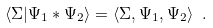<formula> <loc_0><loc_0><loc_500><loc_500>\langle \Sigma | \Psi _ { 1 } * \Psi _ { 2 } \rangle = \langle \Sigma , \Psi _ { 1 } , \Psi _ { 2 } \rangle \ .</formula> 